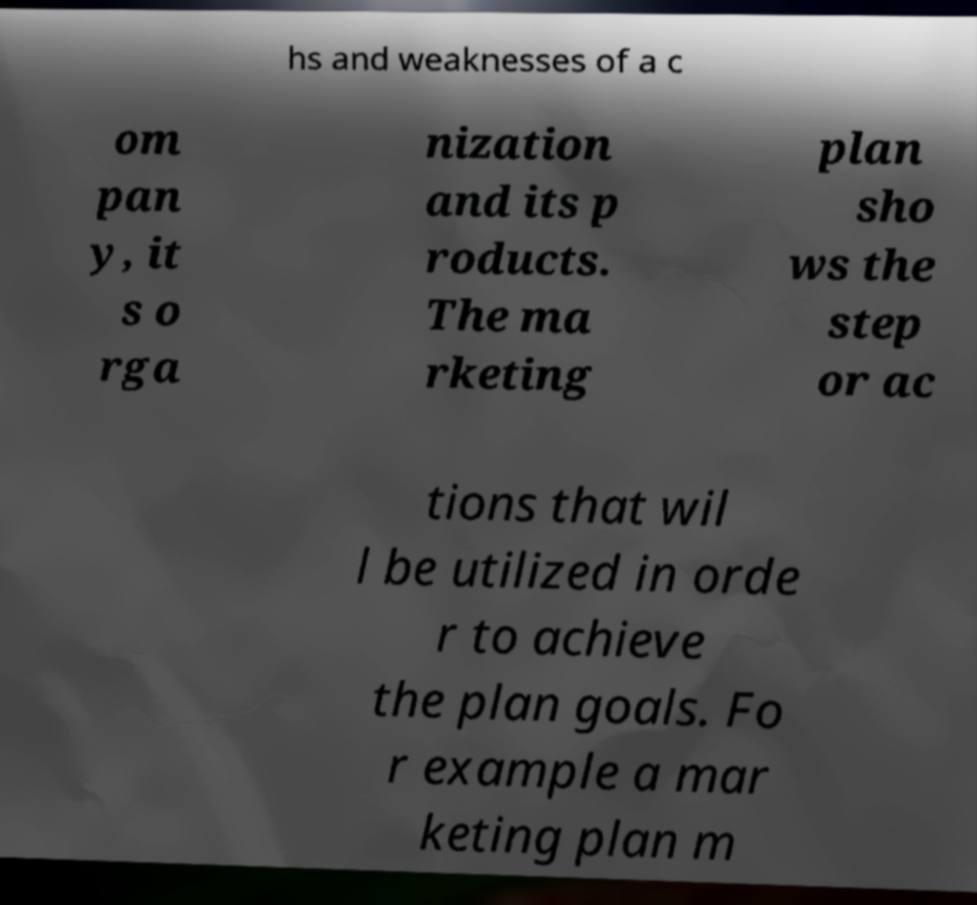I need the written content from this picture converted into text. Can you do that? hs and weaknesses of a c om pan y, it s o rga nization and its p roducts. The ma rketing plan sho ws the step or ac tions that wil l be utilized in orde r to achieve the plan goals. Fo r example a mar keting plan m 